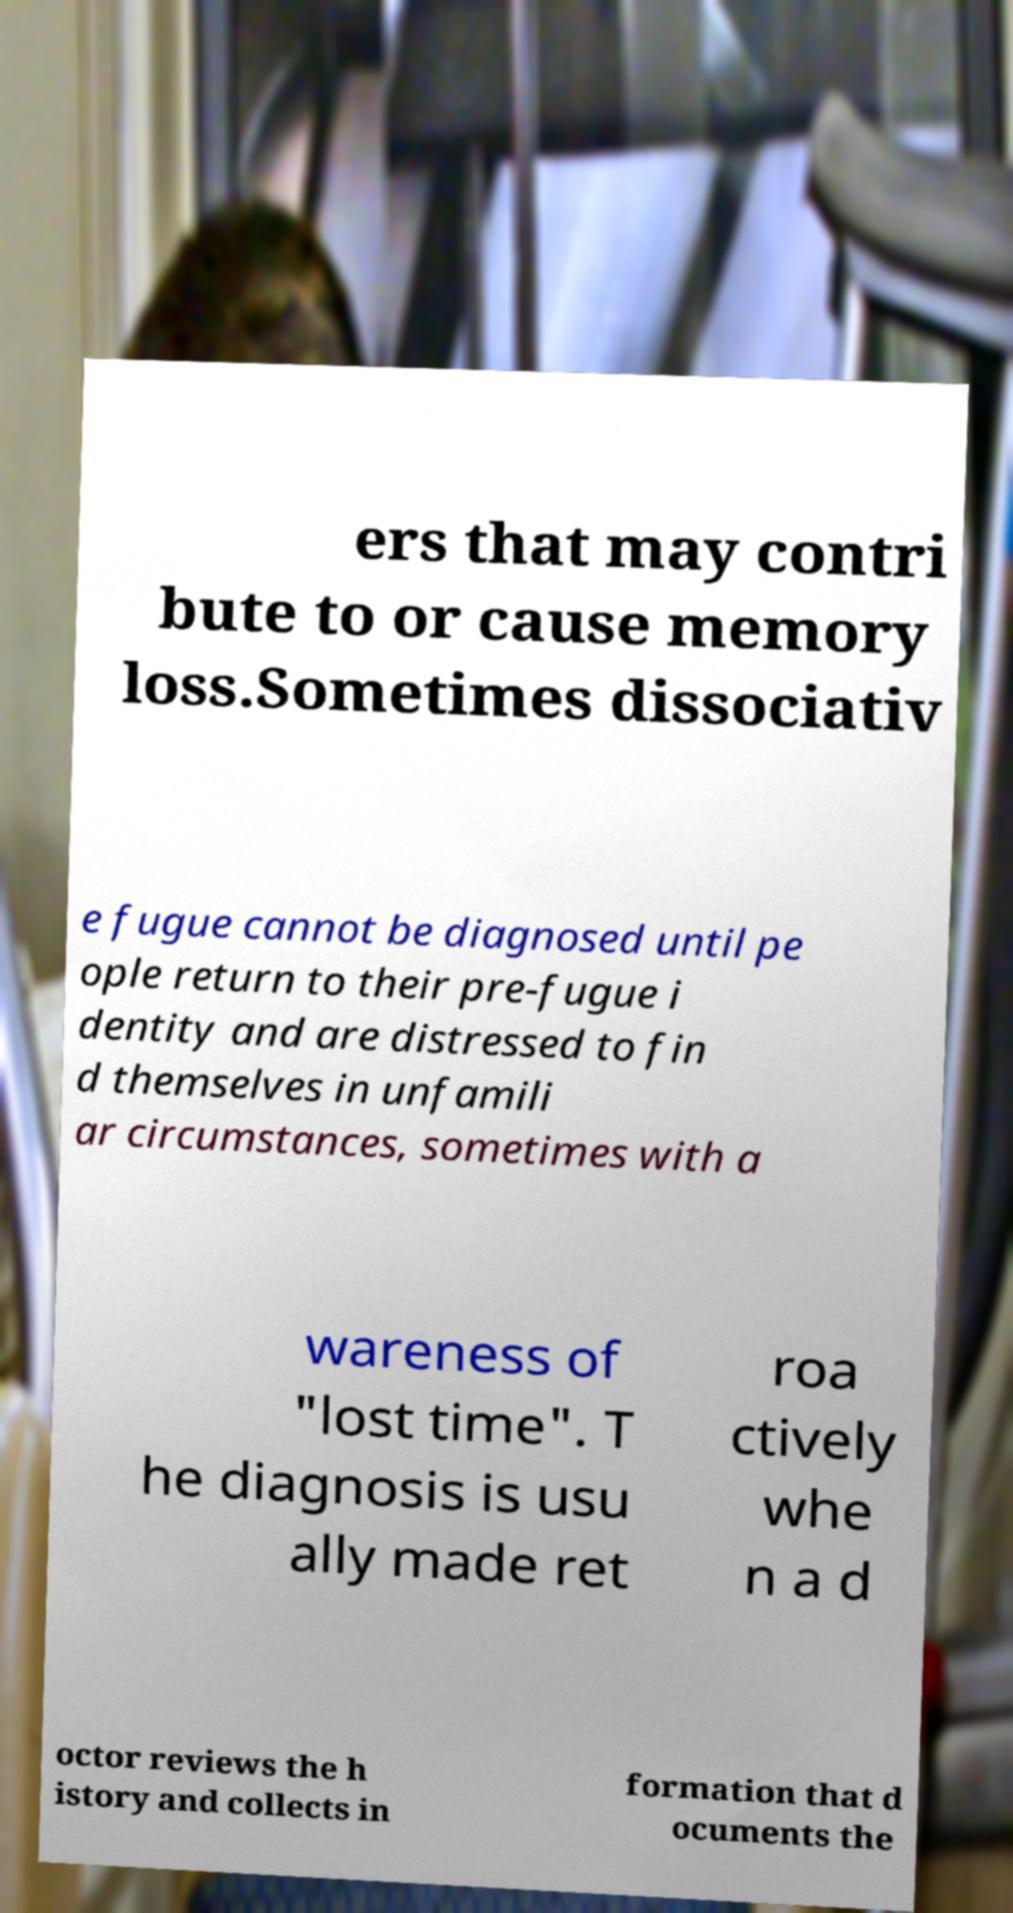Could you assist in decoding the text presented in this image and type it out clearly? ers that may contri bute to or cause memory loss.Sometimes dissociativ e fugue cannot be diagnosed until pe ople return to their pre-fugue i dentity and are distressed to fin d themselves in unfamili ar circumstances, sometimes with a wareness of "lost time". T he diagnosis is usu ally made ret roa ctively whe n a d octor reviews the h istory and collects in formation that d ocuments the 